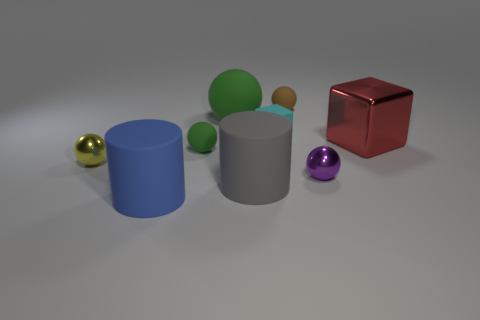There is a blue matte object; is it the same shape as the big gray rubber object on the right side of the small green thing? yes 